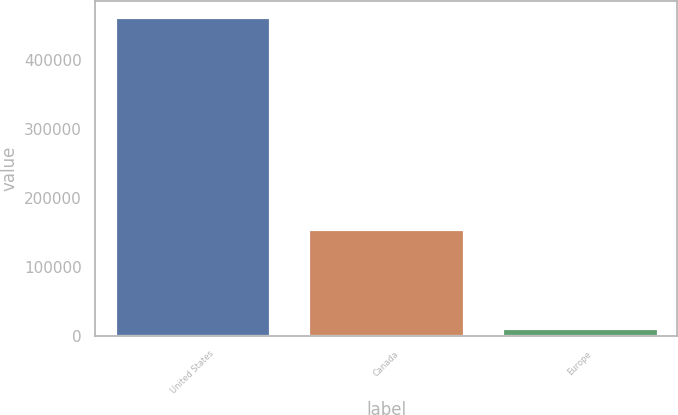Convert chart to OTSL. <chart><loc_0><loc_0><loc_500><loc_500><bar_chart><fcel>United States<fcel>Canada<fcel>Europe<nl><fcel>462443<fcel>155468<fcel>11409<nl></chart> 